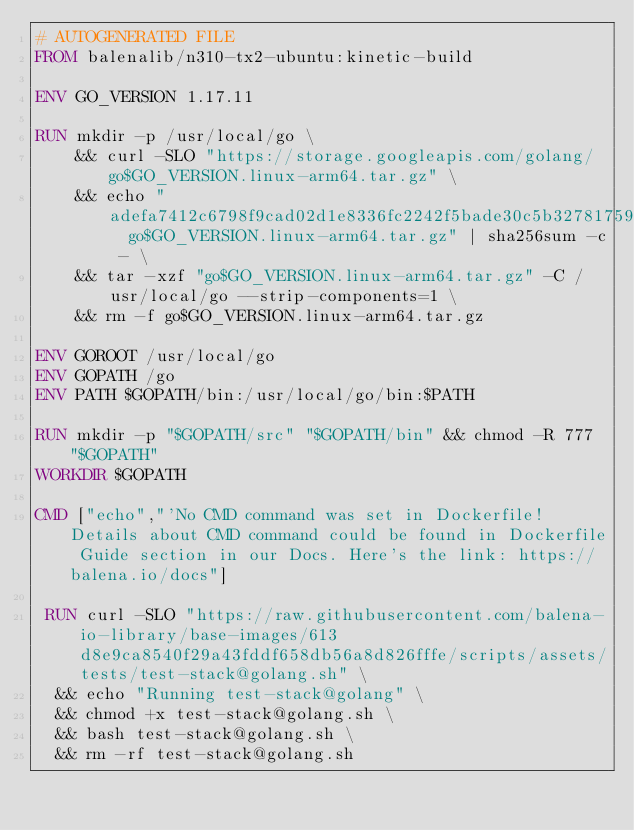<code> <loc_0><loc_0><loc_500><loc_500><_Dockerfile_># AUTOGENERATED FILE
FROM balenalib/n310-tx2-ubuntu:kinetic-build

ENV GO_VERSION 1.17.11

RUN mkdir -p /usr/local/go \
	&& curl -SLO "https://storage.googleapis.com/golang/go$GO_VERSION.linux-arm64.tar.gz" \
	&& echo "adefa7412c6798f9cad02d1e8336fc2242f5bade30c5b32781759181e01961b7  go$GO_VERSION.linux-arm64.tar.gz" | sha256sum -c - \
	&& tar -xzf "go$GO_VERSION.linux-arm64.tar.gz" -C /usr/local/go --strip-components=1 \
	&& rm -f go$GO_VERSION.linux-arm64.tar.gz

ENV GOROOT /usr/local/go
ENV GOPATH /go
ENV PATH $GOPATH/bin:/usr/local/go/bin:$PATH

RUN mkdir -p "$GOPATH/src" "$GOPATH/bin" && chmod -R 777 "$GOPATH"
WORKDIR $GOPATH

CMD ["echo","'No CMD command was set in Dockerfile! Details about CMD command could be found in Dockerfile Guide section in our Docs. Here's the link: https://balena.io/docs"]

 RUN curl -SLO "https://raw.githubusercontent.com/balena-io-library/base-images/613d8e9ca8540f29a43fddf658db56a8d826fffe/scripts/assets/tests/test-stack@golang.sh" \
  && echo "Running test-stack@golang" \
  && chmod +x test-stack@golang.sh \
  && bash test-stack@golang.sh \
  && rm -rf test-stack@golang.sh 
</code> 